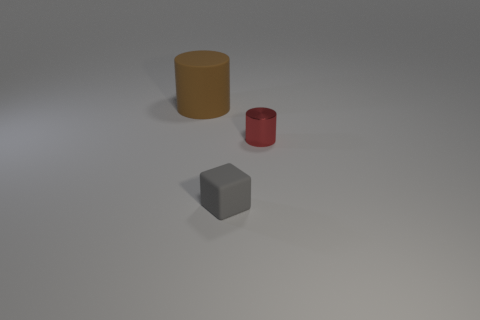Are there any signs of the environment in which these objects are placed? The environment around the objects is minimal, featuring a nondescript, neutral gray surface with a horizon line subtly implied by a gradient shadow, which hints at a large, open, and flat space. The absence of any distinct features suggests a controlled setting, likely a studio used for photographing objects without distractions. 